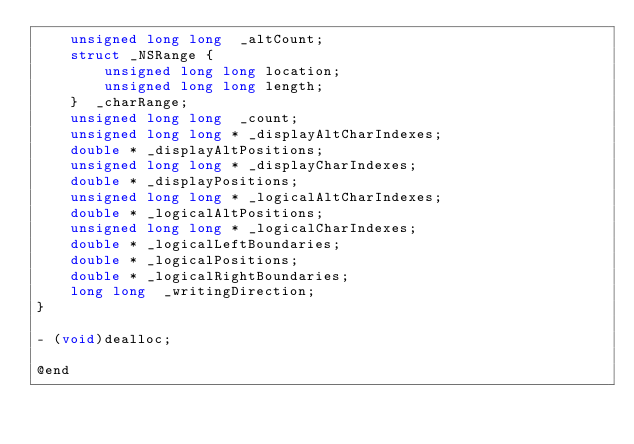<code> <loc_0><loc_0><loc_500><loc_500><_C_>    unsigned long long  _altCount;
    struct _NSRange { 
        unsigned long long location; 
        unsigned long long length; 
    }  _charRange;
    unsigned long long  _count;
    unsigned long long * _displayAltCharIndexes;
    double * _displayAltPositions;
    unsigned long long * _displayCharIndexes;
    double * _displayPositions;
    unsigned long long * _logicalAltCharIndexes;
    double * _logicalAltPositions;
    unsigned long long * _logicalCharIndexes;
    double * _logicalLeftBoundaries;
    double * _logicalPositions;
    double * _logicalRightBoundaries;
    long long  _writingDirection;
}

- (void)dealloc;

@end
</code> 